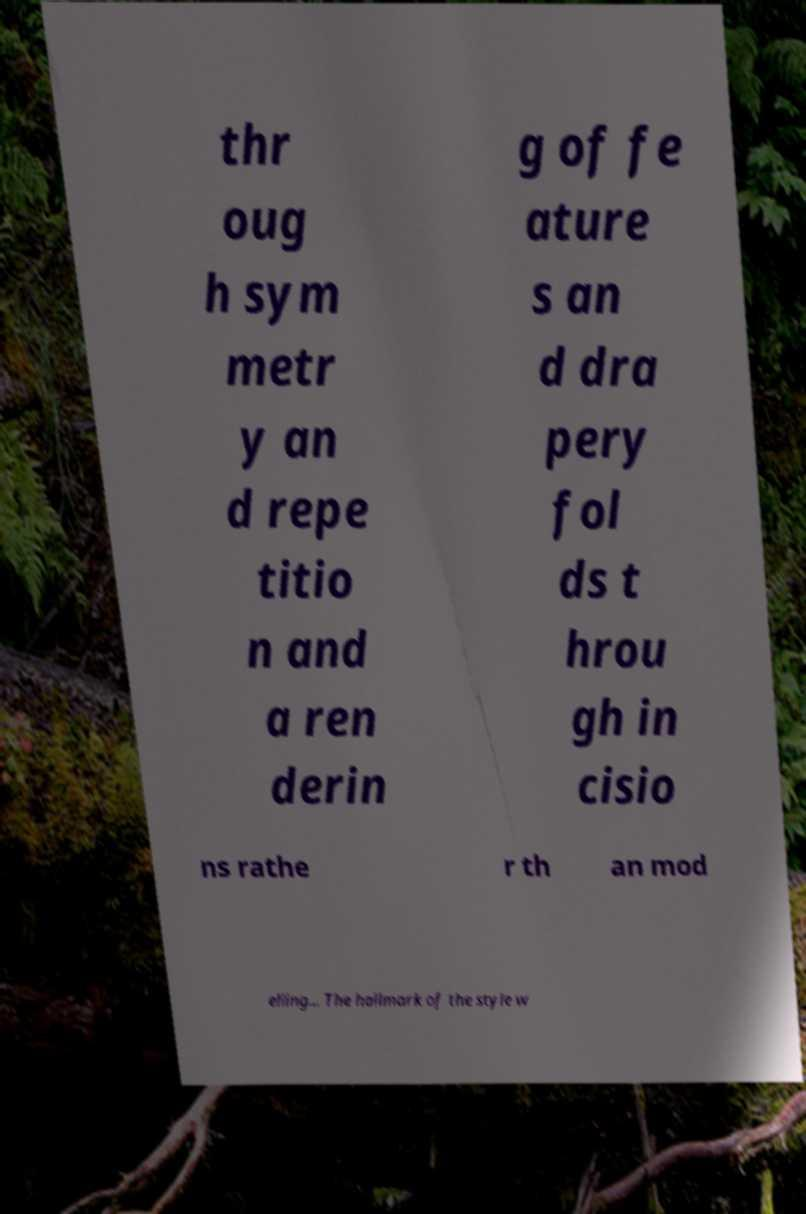Please identify and transcribe the text found in this image. thr oug h sym metr y an d repe titio n and a ren derin g of fe ature s an d dra pery fol ds t hrou gh in cisio ns rathe r th an mod elling... The hallmark of the style w 